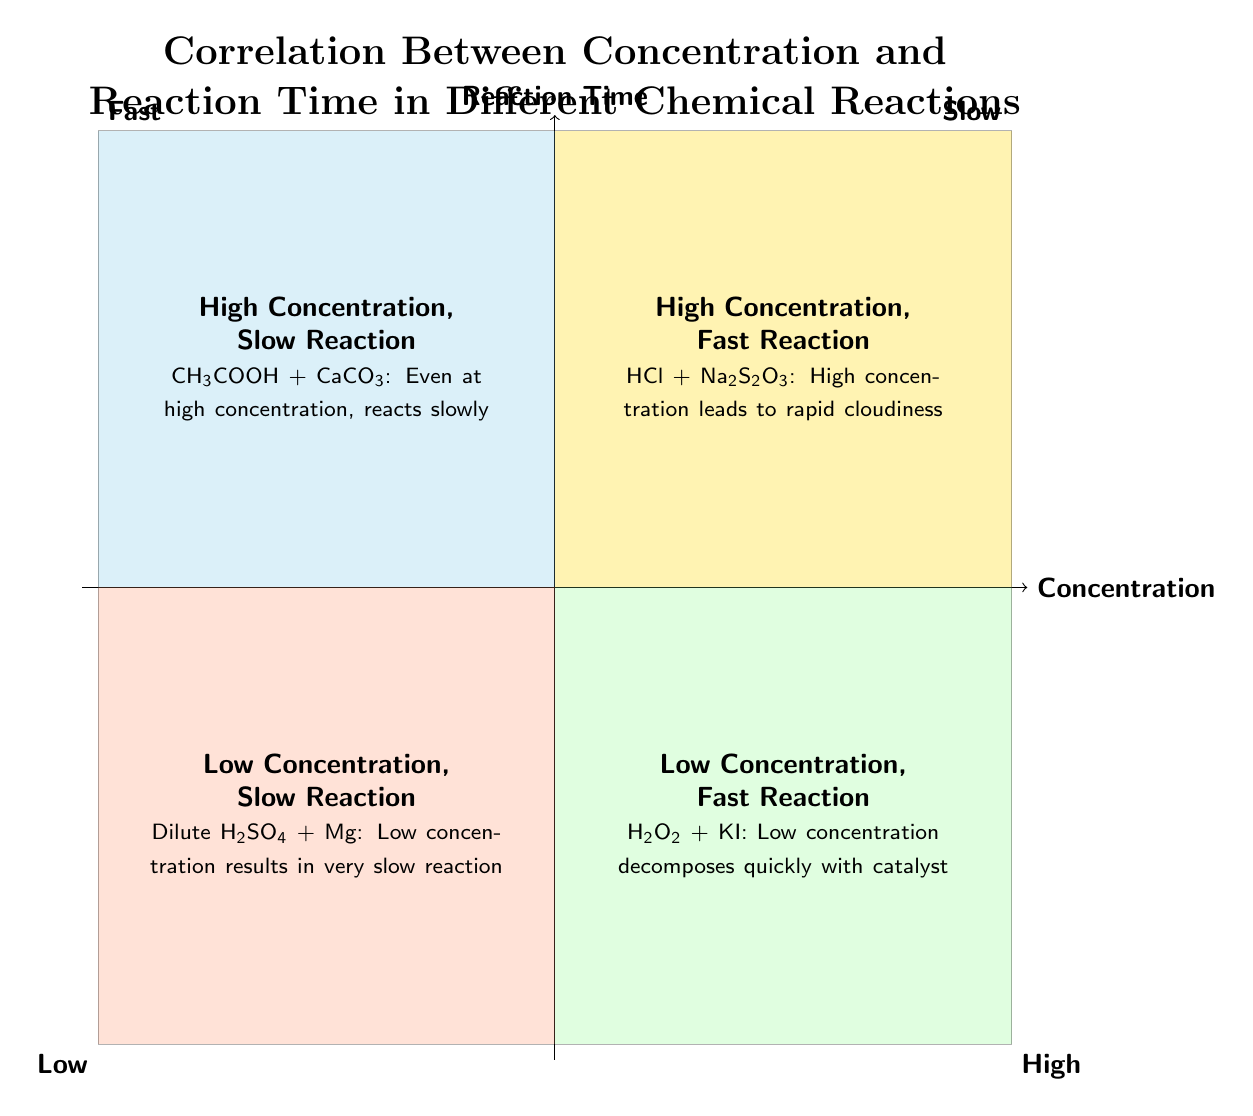What is in the "High Concentration, Fast Reaction" quadrant? The quadrant lists "Hydrochloric Acid (HCl) and Sodium Thiosulfate (Na2S2O3)", which is given as the chemical reaction with a description indicating that a high concentration of HCl leads to rapid cloudiness.
Answer: Hydrochloric Acid (HCl) and Sodium Thiosulfate (Na2S2O3) Which reaction shows a "Low Concentration, Slow Reaction"? In the quadrant labeled "Low Concentration, Slow Reaction", the reaction described is "Dilute Sulfuric Acid (H2SO4) and Magnesium (Mg)", with the additional note that it results in a very slow reaction.
Answer: Dilute Sulfuric Acid (H2SO4) and Magnesium (Mg) What does a "High Concentration" usually relate to in this diagram? In the upper quadrants of the chart, both the "High Concentration, Fast Reaction" and "High Concentration, Slow Reaction" quadrants are present. This indicates that a high concentration can either lead to fast reactions or slow reactions, as evidenced by HCl and acetic acid, respectively.
Answer: Fast or Slow reactions How many reactions are listed in the "Low Concentration, Fast Reaction" quadrant? The quadrant displays only one reaction: "Hydrogen Peroxide (H2O2) and Potassium Iodide (KI)", indicating that there is just one reaction in that specific quadrant.
Answer: One Which quadrant contains the reaction involving acetic acid? The "High Concentration, Slow Reaction" quadrant includes the reaction of acetic acid with calcium carbonate, which is denoted by the chemical formula CH3COOH + CaCO3 in the diagram.
Answer: High Concentration, Slow Reaction What is the general trend observed regarding concentration and reaction time? The diagram shows that higher concentrations can lead to either fast or slow reactions, while lower concentrations are generally associated with fast reactions (as seen with H2O2) but also include slow reactions (as seen with dilute sulfuric acid). This dual behavior underscores the complexity of reaction dynamics.
Answer: Complex relationship What indicates a fast reaction in this chart? The "Fast" reaction classification is represented in quadrants that either have low or high concentration, specifically marked in the upper regions of the chart, with examples like HCl and H2O2 reactions contributing to these classifications.
Answer: Upper quadrants Which catalyst is mentioned for the reaction with low concentration? The reaction with low concentration involving "Hydrogen Peroxide (H2O2) and Potassium Iodide (KI)" points out that KI acts as the catalyst for the rapid decomposition of H2O2, suggesting that catalysts play a significant role even at lower concentrations.
Answer: Potassium Iodide (KI) 